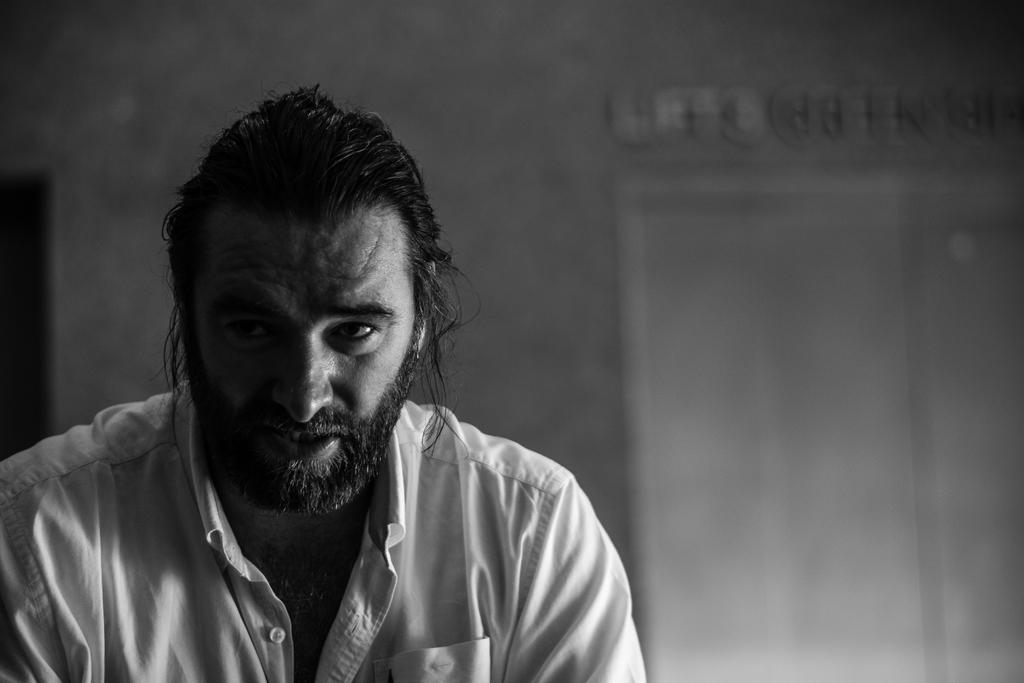What is present in the image? There is a man in the image. What can be seen in the background of the image? There appears to be a door in the background of the image. What type of fang can be seen in the image? There is no fang present in the image. Who is the man in the image visiting, and is she his grandmother? The image does not provide information about the man's relationship with any other person, nor does it show any other individuals. 